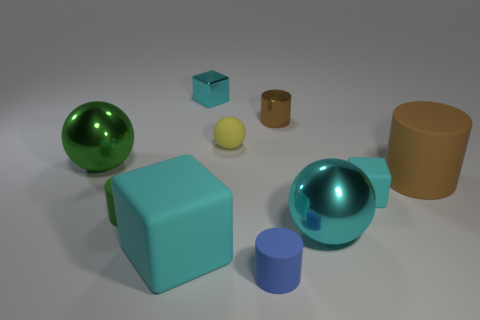How many brown cylinders must be subtracted to get 1 brown cylinders? 1 Subtract all green spheres. How many spheres are left? 2 Subtract 3 cylinders. How many cylinders are left? 1 Subtract all green cylinders. How many cylinders are left? 3 Subtract all brown spheres. How many brown cylinders are left? 2 Subtract all blocks. How many objects are left? 7 Add 7 cyan metallic cylinders. How many cyan metallic cylinders exist? 7 Subtract 0 green blocks. How many objects are left? 10 Subtract all brown cubes. Subtract all red balls. How many cubes are left? 3 Subtract all cyan metallic objects. Subtract all metallic cylinders. How many objects are left? 7 